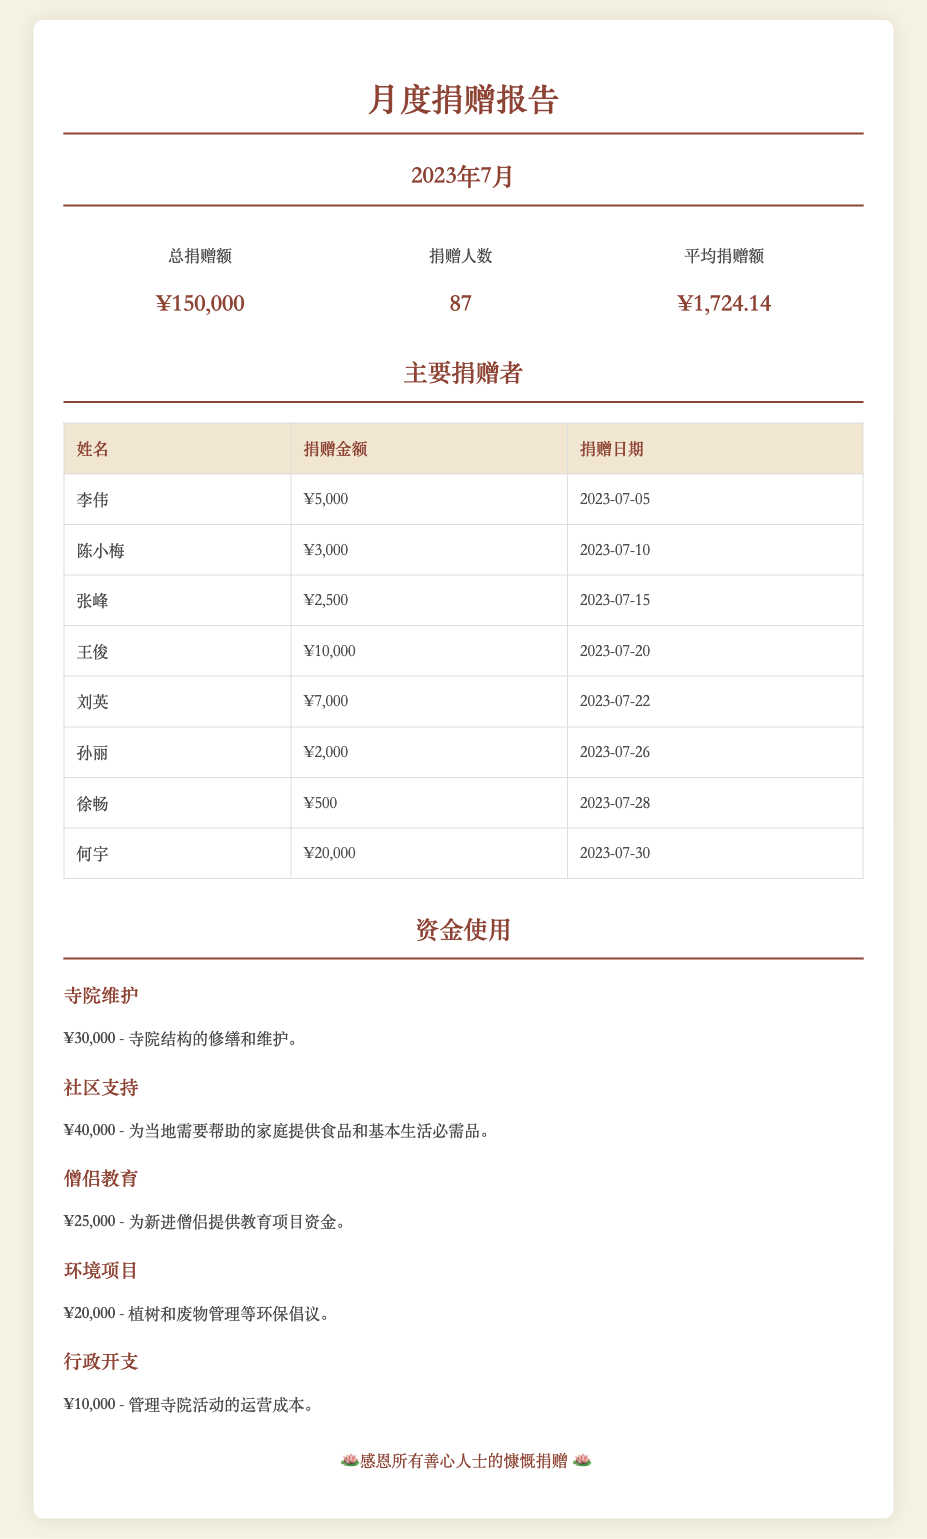总捐赠额是多少？ 文档中概述部分提到的总捐赠额为150,000元。
Answer: ¥150,000 捐赠人数为多少？ 概述部分列出了参与捐赠的人数为87。
Answer: 87 谁是主要捐赠者中捐赠金额最高的？ 表格中的主要捐赠者显示何宇捐赠金额最高，为20,000元。
Answer: 何宇 用于寺院维护的资金是多少？ 文档的资金使用部分提到寺院维护的资金为30,000元。
Answer: ¥30,000 平均捐赠额是多少？ 概述部分提供的平均捐赠额为1,724.14元。
Answer: ¥1,724.14 社区支持的资金用途是什么？ 资金使用栏目中描述社区支持为提供食品和基本生活必需品。
Answer: 提供食品和基本生活必需品 七月的捐赠中，陈小梅的捐赠日期是什么？ 在主要捐赠者表格中，陈小梅的捐赠日期列为2023年7月10日。
Answer: 2023年7月10日 资金使用中，环境项目的金额是多少？ 资金使用部分中指出环境项目的资金为20,000元。
Answer: ¥20,000 该报告中提到了多少个资金使用项目？ 在资金使用部分列出了五个不同的项目。
Answer: 5 主要捐赠者的表格中有多少个捐赠者？ 主要捐赠者表格中显示有8个捐赠者的记录。
Answer: 8 